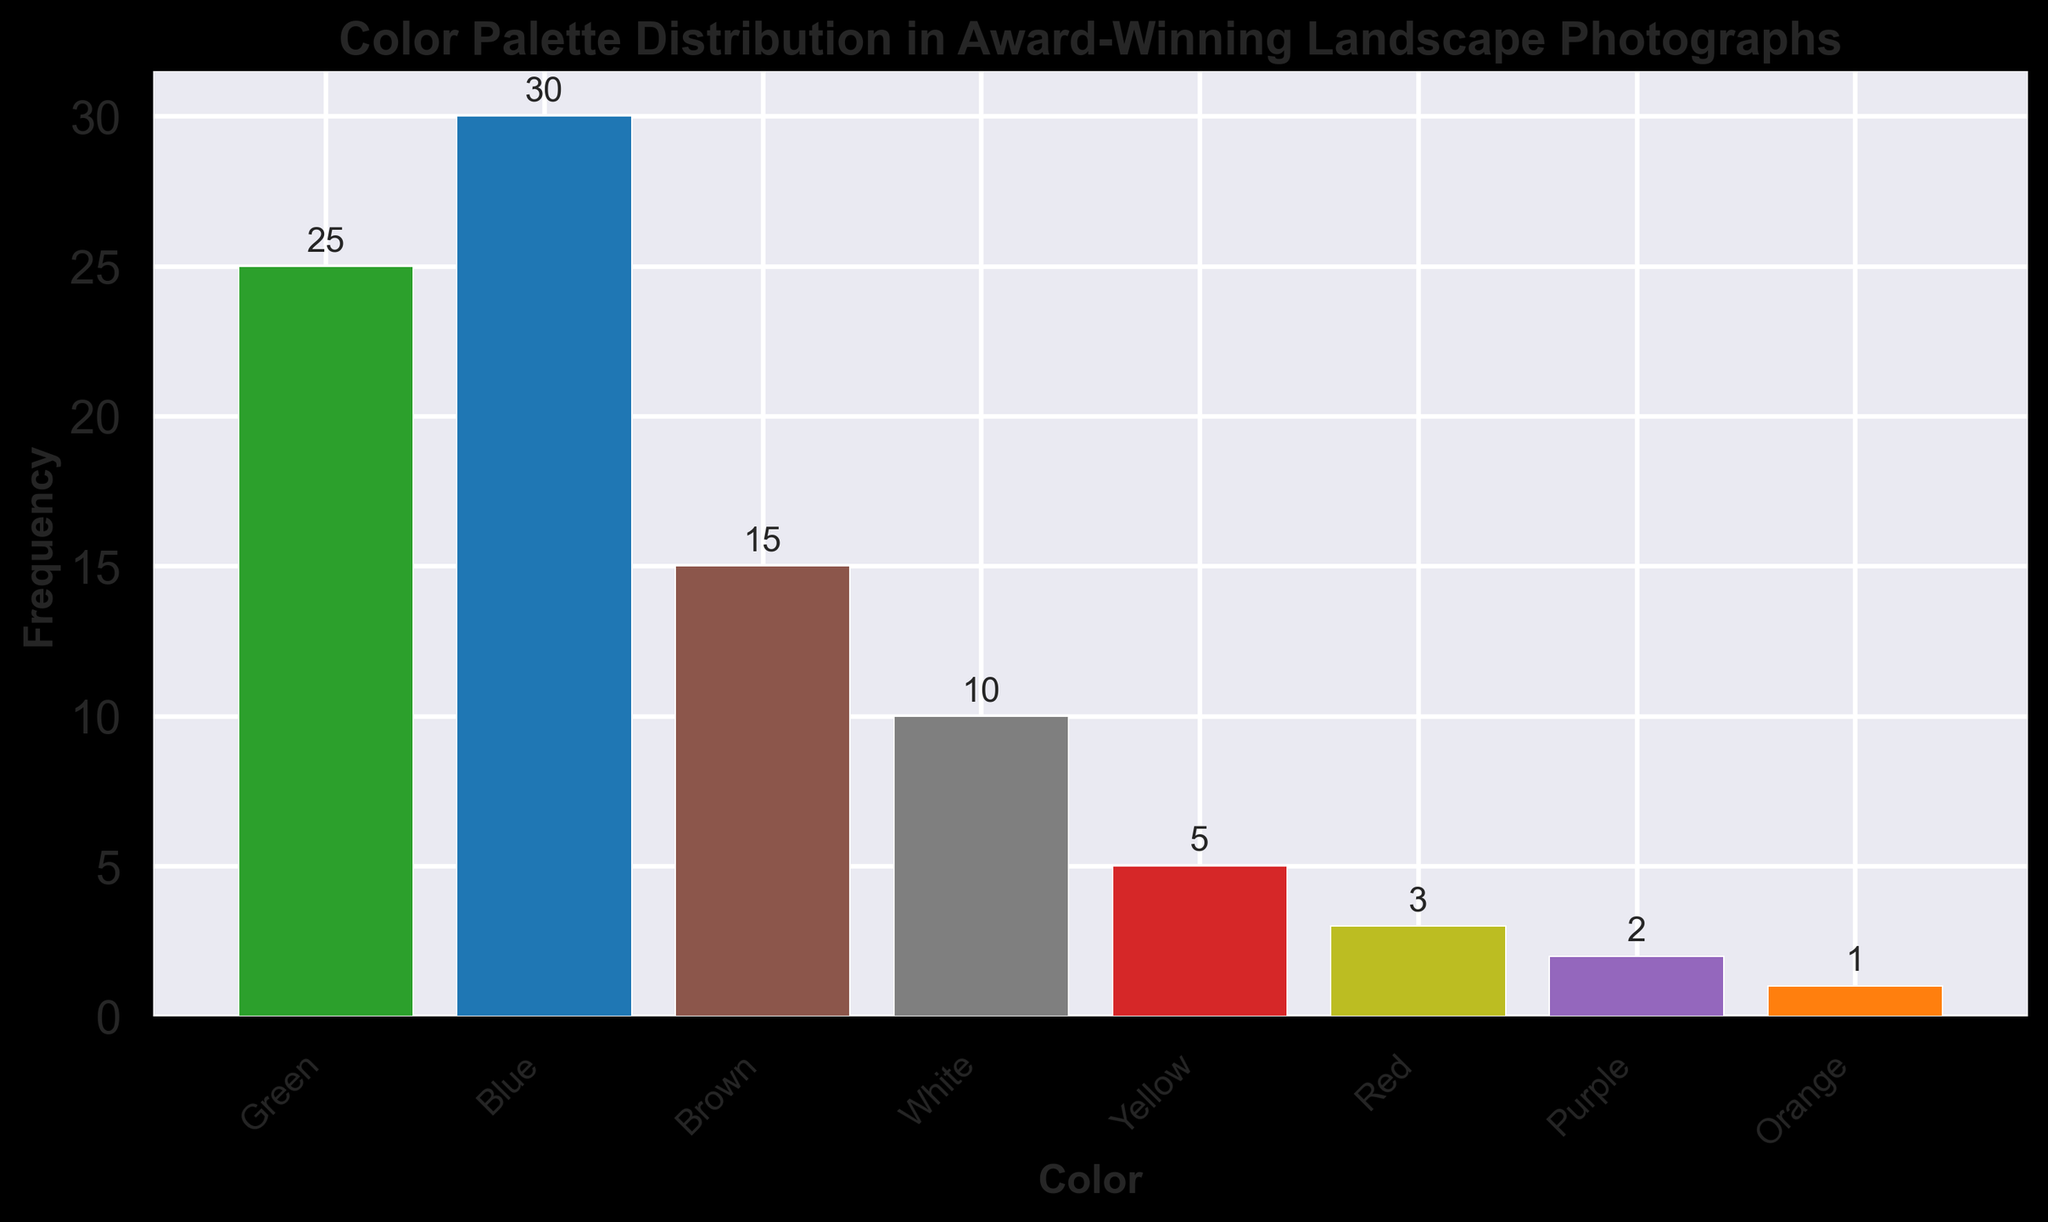What's the most frequently used color in award-winning landscape photographs? To find the most frequently used color, look at the height of the bars in the histogram and identify the tallest bar. The color corresponding to the tallest bar is the most frequently used color. The tallest bar corresponds to the color 'Blue' with a frequency of 30.
Answer: Blue Which two colors have the nearest frequency and what are their frequencies? To find the two colors with the nearest frequency, examine the frequencies of all the colors and identify the two that are closest to each other. Green (25) and Brown (15) are closest in frequency with a difference of 10. Therefore, Green and Brown have the nearest frequencies.
Answer: Green (25) and Brown (15) How much more frequently is Blue used compared to Red in these photographs? To determine how much more frequently Blue is used compared to Red, subtract the frequency of Red from the frequency of Blue. The frequency of Blue is 30 and that of Red is 3, so 30 - 3 = 27.
Answer: 27 What is the combined frequency of the three least frequently used colors? Identify the three least frequently used colors by finding the colors with the smallest bar heights. Orange (1), Purple (2), and Red (3) are the least frequent. Add their frequencies: 1 + 2 + 3 = 6.
Answer: 6 Which color appears less frequently than White but more frequently than Purple? To find the color that appears less frequently than White but more frequently than Purple, identify the frequency of White (10) and Purple (2) first. The color that falls between these frequencies is Red (3).
Answer: Red What is the average (mean) frequency of Green, Blue, and Brown? To calculate the average frequency, add the frequencies of Green (25), Blue (30), and Brown (15) and divide by the number of colors, which is 3. (25 + 30 + 15) / 3 = 23.33
Answer: 23.33 Is Green used more frequently in award-winning landscape photographs than Yellow and White combined? First, determine the frequency of Green (25). Then, add the frequencies of Yellow (5) and White (10). Compare these sums: 5 + 10 = 15 which is less than 25, so yes, Green is used more frequently than the combined Yellow and White.
Answer: Yes How many colors have a frequency of 10 or more? Count the number of bars that have a height (frequency) of 10 or more. The colors Green (25), Blue (30), and Brown (15) meet this criterion. Thus, there are three colors.
Answer: 3 What percentage of the colors has a frequency of 5 or more? Count the total number of colors (8). Identify the colors with frequency equal to or above 5: Green (25), Blue (30), Brown (15), White (10), and Yellow (5). There are 5 such colors. Calculate the percentage: (5/8)*100 = 62.5%.
Answer: 62.5% 